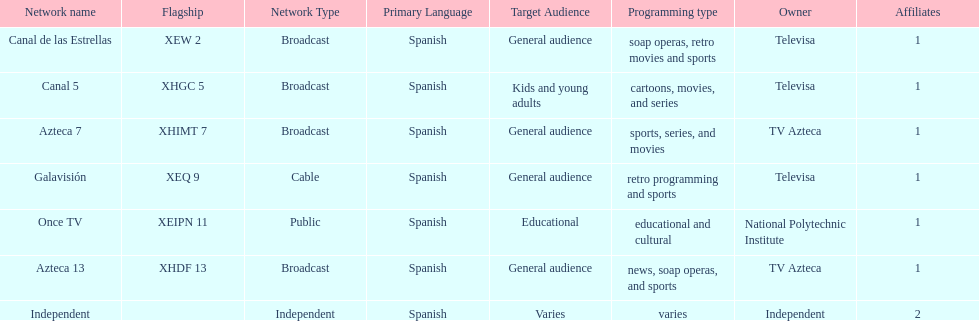How many affiliates does galavision have? 1. 